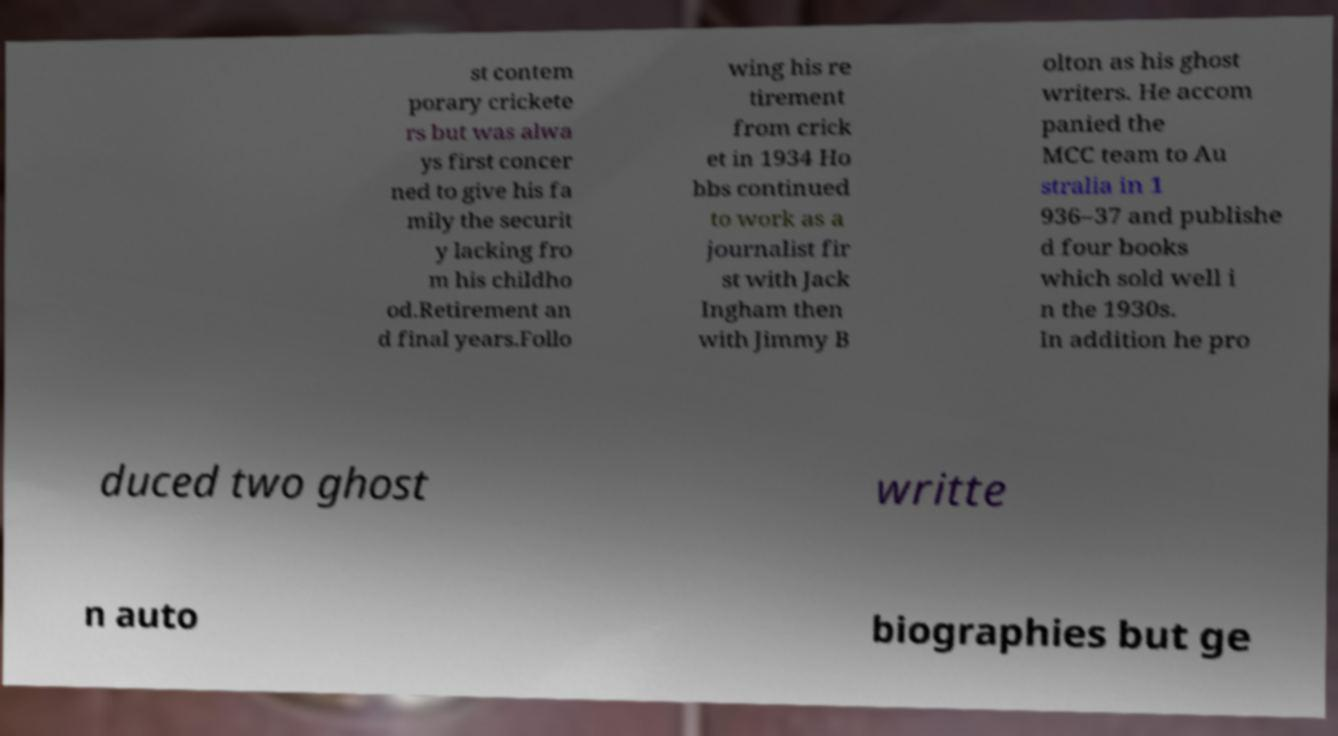For documentation purposes, I need the text within this image transcribed. Could you provide that? st contem porary crickete rs but was alwa ys first concer ned to give his fa mily the securit y lacking fro m his childho od.Retirement an d final years.Follo wing his re tirement from crick et in 1934 Ho bbs continued to work as a journalist fir st with Jack Ingham then with Jimmy B olton as his ghost writers. He accom panied the MCC team to Au stralia in 1 936–37 and publishe d four books which sold well i n the 1930s. In addition he pro duced two ghost writte n auto biographies but ge 